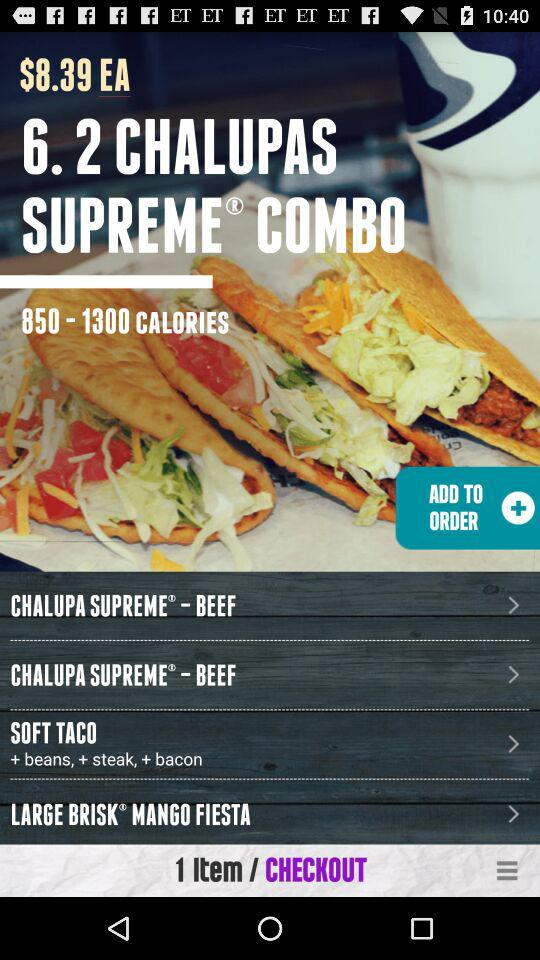What is the number of items? The number of items is 1. 